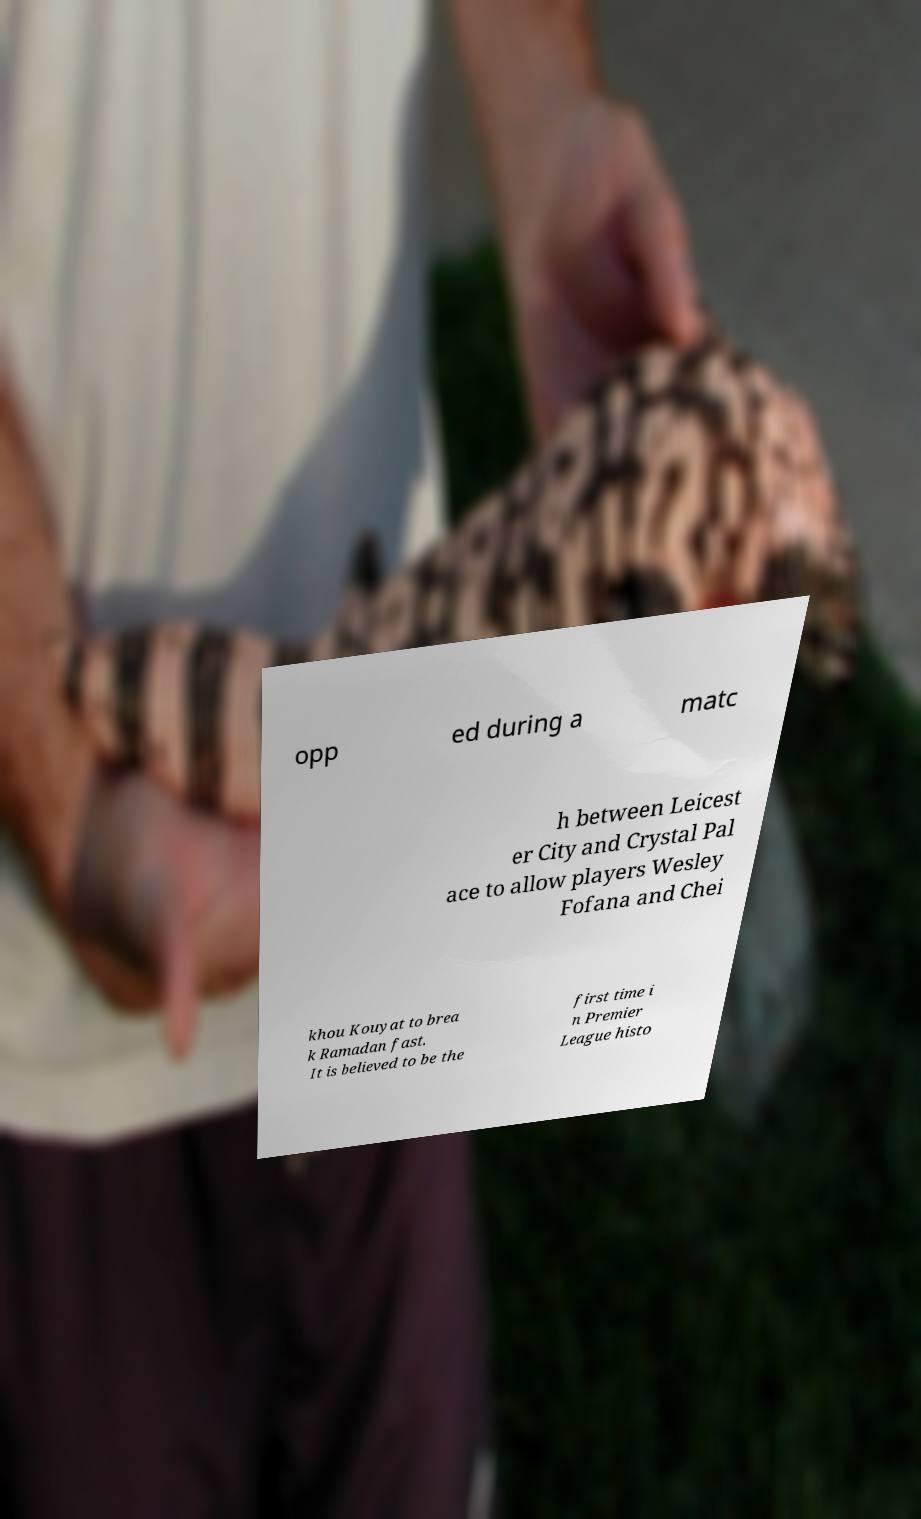For documentation purposes, I need the text within this image transcribed. Could you provide that? opp ed during a matc h between Leicest er City and Crystal Pal ace to allow players Wesley Fofana and Chei khou Kouyat to brea k Ramadan fast. It is believed to be the first time i n Premier League histo 